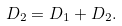Convert formula to latex. <formula><loc_0><loc_0><loc_500><loc_500>D _ { 2 } = D _ { 1 } + D _ { 2 } .</formula> 